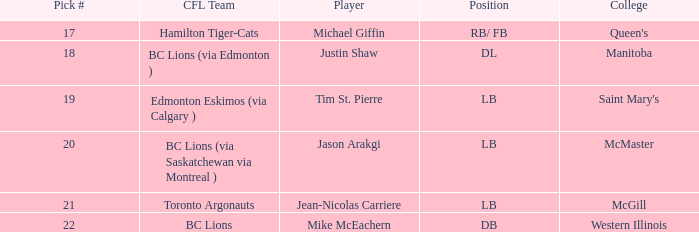How many cfl teams had pick # 21? 1.0. 